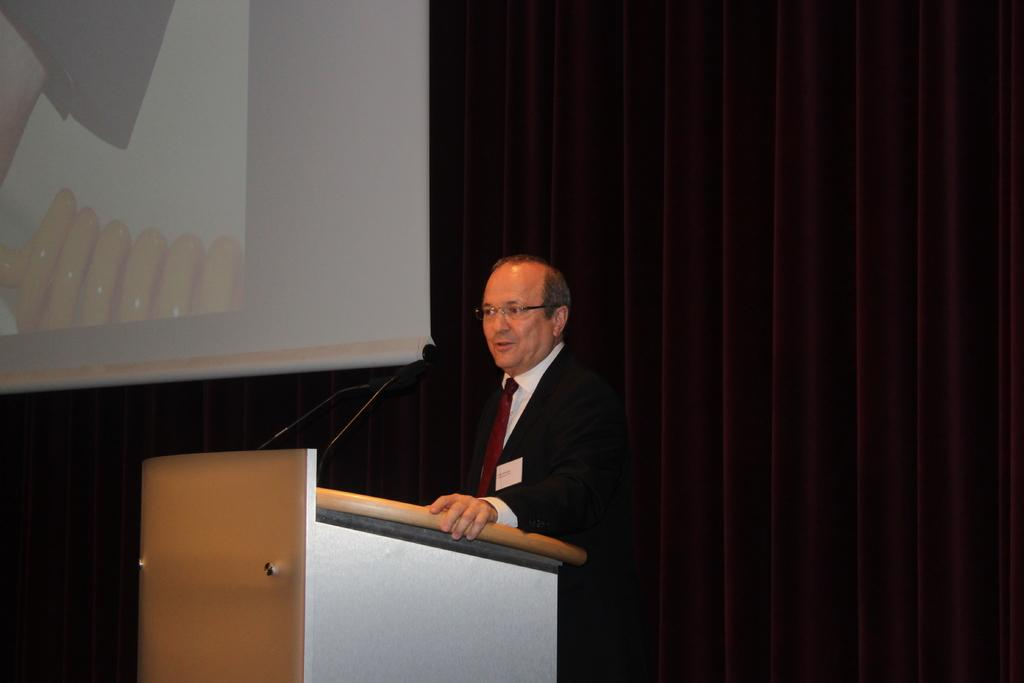What is the man in the image doing? The man is standing in front of a podium. What is on the podium? The podium has microphones on it. What can be seen in the background of the image? There is a screen and a curtain in the background of the image. What type of current is flowing through the system in the image? There is no mention of a system or current in the image; it features a man standing in front of a podium with microphones and a background with a screen and curtain. 